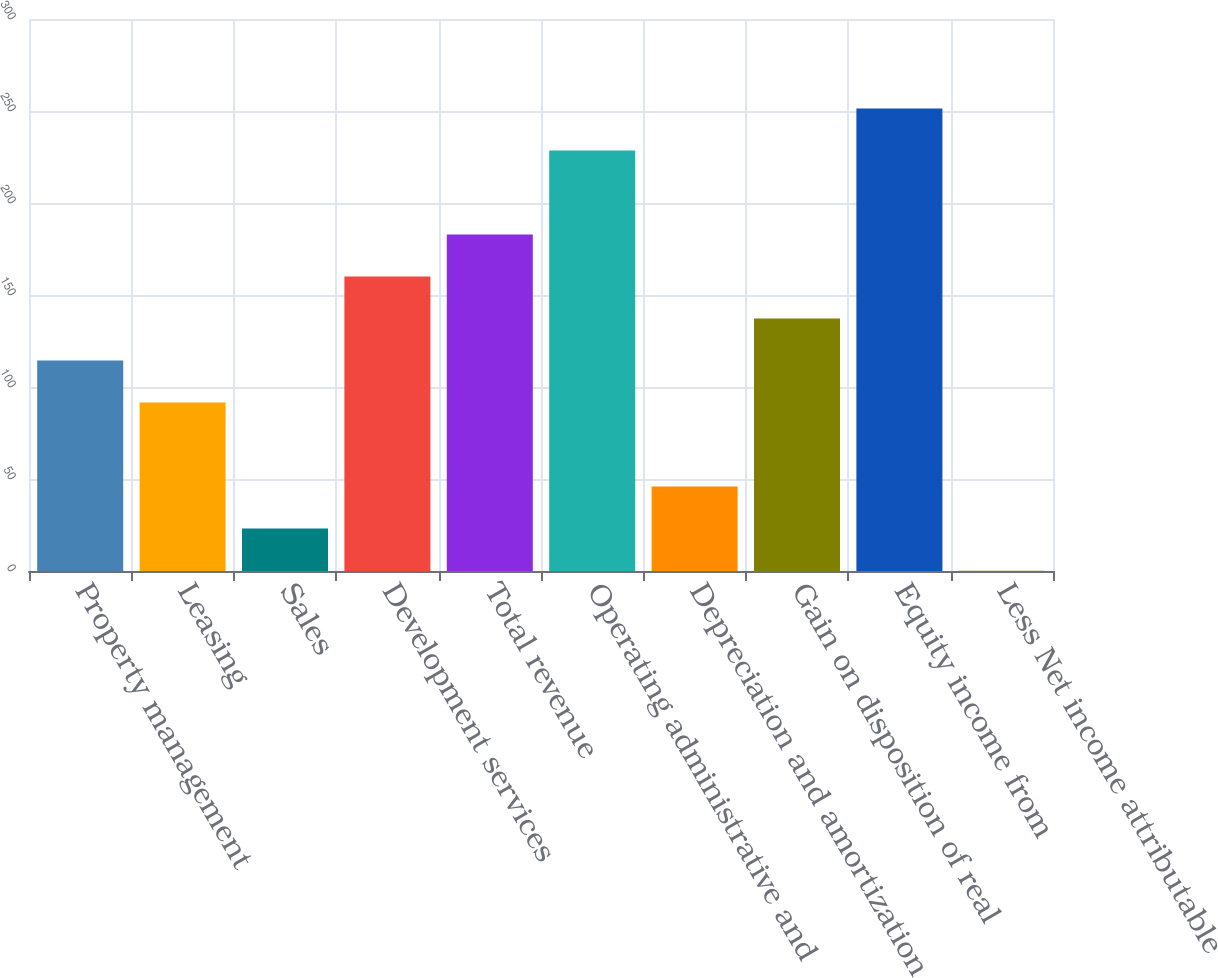Convert chart. <chart><loc_0><loc_0><loc_500><loc_500><bar_chart><fcel>Property management<fcel>Leasing<fcel>Sales<fcel>Development services<fcel>Total revenue<fcel>Operating administrative and<fcel>Depreciation and amortization<fcel>Gain on disposition of real<fcel>Equity income from<fcel>Less Net income attributable<nl><fcel>114.35<fcel>91.52<fcel>23.03<fcel>160.01<fcel>182.84<fcel>228.5<fcel>45.86<fcel>137.18<fcel>251.33<fcel>0.2<nl></chart> 